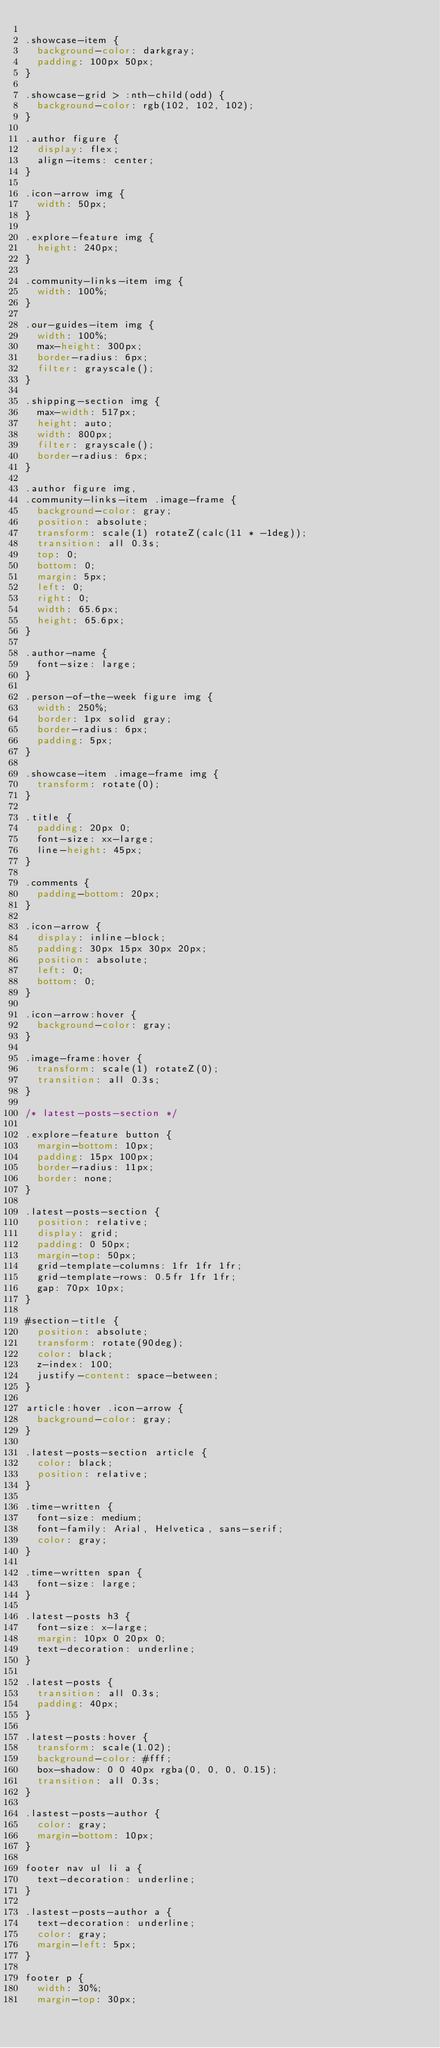Convert code to text. <code><loc_0><loc_0><loc_500><loc_500><_CSS_>
.showcase-item {
  background-color: darkgray;
  padding: 100px 50px;
}

.showcase-grid > :nth-child(odd) {
  background-color: rgb(102, 102, 102);
}

.author figure {
  display: flex;
  align-items: center;
}

.icon-arrow img {
  width: 50px;
}

.explore-feature img {
  height: 240px;
}

.community-links-item img {
  width: 100%;
}

.our-guides-item img {
  width: 100%;
  max-height: 300px;
  border-radius: 6px;
  filter: grayscale();
}

.shipping-section img {
  max-width: 517px;
  height: auto;
  width: 800px;
  filter: grayscale();
  border-radius: 6px;
}

.author figure img,
.community-links-item .image-frame {
  background-color: gray;
  position: absolute;
  transform: scale(1) rotateZ(calc(11 * -1deg));
  transition: all 0.3s;
  top: 0;
  bottom: 0;
  margin: 5px;
  left: 0;
  right: 0;
  width: 65.6px;
  height: 65.6px;
}

.author-name {
  font-size: large;
}

.person-of-the-week figure img {
  width: 250%;
  border: 1px solid gray;
  border-radius: 6px;
  padding: 5px;
}

.showcase-item .image-frame img {
  transform: rotate(0);
}

.title {
  padding: 20px 0;
  font-size: xx-large;
  line-height: 45px;
}

.comments {
  padding-bottom: 20px;
}

.icon-arrow {
  display: inline-block;
  padding: 30px 15px 30px 20px;
  position: absolute;
  left: 0;
  bottom: 0;
}

.icon-arrow:hover {
  background-color: gray;
}

.image-frame:hover {
  transform: scale(1) rotateZ(0);
  transition: all 0.3s;
}

/* latest-posts-section */

.explore-feature button {
  margin-bottom: 10px;
  padding: 15px 100px;
  border-radius: 11px;
  border: none;
}

.latest-posts-section {
  position: relative;
  display: grid;
  padding: 0 50px;
  margin-top: 50px;
  grid-template-columns: 1fr 1fr 1fr;
  grid-template-rows: 0.5fr 1fr 1fr;
  gap: 70px 10px;
}

#section-title {
  position: absolute;
  transform: rotate(90deg);
  color: black;
  z-index: 100;
  justify-content: space-between;
}

article:hover .icon-arrow {
  background-color: gray;
}

.latest-posts-section article {
  color: black;
  position: relative;
}

.time-written {
  font-size: medium;
  font-family: Arial, Helvetica, sans-serif;
  color: gray;
}

.time-written span {
  font-size: large;
}

.latest-posts h3 {
  font-size: x-large;
  margin: 10px 0 20px 0;
  text-decoration: underline;
}

.latest-posts {
  transition: all 0.3s;
  padding: 40px;
}

.latest-posts:hover {
  transform: scale(1.02);
  background-color: #fff;
  box-shadow: 0 0 40px rgba(0, 0, 0, 0.15);
  transition: all 0.3s;
}

.lastest-posts-author {
  color: gray;
  margin-bottom: 10px;
}

footer nav ul li a {
  text-decoration: underline;
}

.lastest-posts-author a {
  text-decoration: underline;
  color: gray;
  margin-left: 5px;
}

footer p {
  width: 30%;
  margin-top: 30px;</code> 